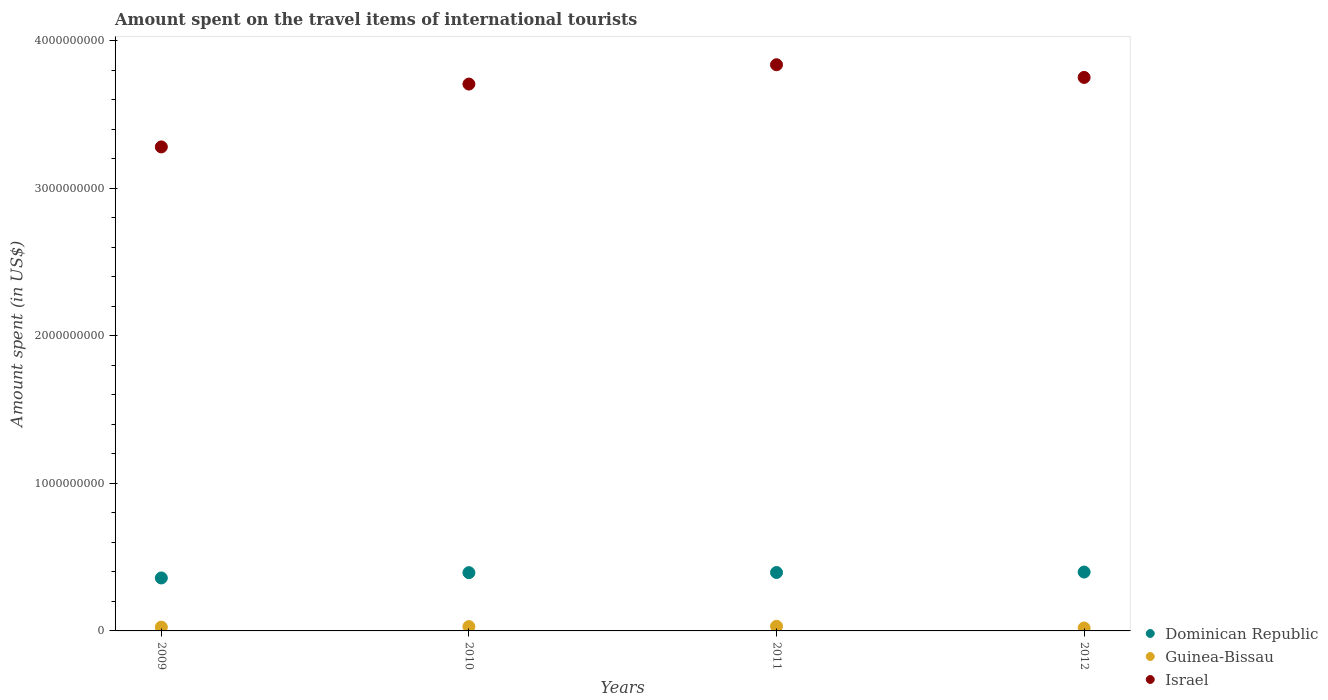What is the amount spent on the travel items of international tourists in Dominican Republic in 2012?
Provide a succinct answer. 3.99e+08. Across all years, what is the maximum amount spent on the travel items of international tourists in Dominican Republic?
Ensure brevity in your answer.  3.99e+08. Across all years, what is the minimum amount spent on the travel items of international tourists in Dominican Republic?
Provide a short and direct response. 3.59e+08. In which year was the amount spent on the travel items of international tourists in Israel maximum?
Your response must be concise. 2011. What is the total amount spent on the travel items of international tourists in Guinea-Bissau in the graph?
Ensure brevity in your answer.  1.06e+08. What is the difference between the amount spent on the travel items of international tourists in Israel in 2011 and that in 2012?
Provide a short and direct response. 8.60e+07. What is the difference between the amount spent on the travel items of international tourists in Dominican Republic in 2011 and the amount spent on the travel items of international tourists in Israel in 2009?
Your response must be concise. -2.88e+09. What is the average amount spent on the travel items of international tourists in Israel per year?
Ensure brevity in your answer.  3.64e+09. In the year 2011, what is the difference between the amount spent on the travel items of international tourists in Israel and amount spent on the travel items of international tourists in Dominican Republic?
Give a very brief answer. 3.44e+09. What is the ratio of the amount spent on the travel items of international tourists in Dominican Republic in 2009 to that in 2010?
Offer a terse response. 0.91. Is the amount spent on the travel items of international tourists in Guinea-Bissau in 2010 less than that in 2012?
Make the answer very short. No. Is the difference between the amount spent on the travel items of international tourists in Israel in 2010 and 2011 greater than the difference between the amount spent on the travel items of international tourists in Dominican Republic in 2010 and 2011?
Your response must be concise. No. What is the difference between the highest and the lowest amount spent on the travel items of international tourists in Dominican Republic?
Keep it short and to the point. 4.00e+07. In how many years, is the amount spent on the travel items of international tourists in Dominican Republic greater than the average amount spent on the travel items of international tourists in Dominican Republic taken over all years?
Provide a short and direct response. 3. Does the amount spent on the travel items of international tourists in Guinea-Bissau monotonically increase over the years?
Your answer should be compact. No. Is the amount spent on the travel items of international tourists in Guinea-Bissau strictly greater than the amount spent on the travel items of international tourists in Israel over the years?
Offer a terse response. No. Is the amount spent on the travel items of international tourists in Israel strictly less than the amount spent on the travel items of international tourists in Guinea-Bissau over the years?
Give a very brief answer. No. How many years are there in the graph?
Your answer should be compact. 4. What is the difference between two consecutive major ticks on the Y-axis?
Your answer should be very brief. 1.00e+09. Are the values on the major ticks of Y-axis written in scientific E-notation?
Provide a short and direct response. No. Does the graph contain any zero values?
Make the answer very short. No. Where does the legend appear in the graph?
Keep it short and to the point. Bottom right. How are the legend labels stacked?
Make the answer very short. Vertical. What is the title of the graph?
Give a very brief answer. Amount spent on the travel items of international tourists. Does "Tanzania" appear as one of the legend labels in the graph?
Your answer should be very brief. No. What is the label or title of the Y-axis?
Offer a very short reply. Amount spent (in US$). What is the Amount spent (in US$) of Dominican Republic in 2009?
Make the answer very short. 3.59e+08. What is the Amount spent (in US$) of Guinea-Bissau in 2009?
Your answer should be compact. 2.57e+07. What is the Amount spent (in US$) of Israel in 2009?
Make the answer very short. 3.28e+09. What is the Amount spent (in US$) of Dominican Republic in 2010?
Your answer should be very brief. 3.95e+08. What is the Amount spent (in US$) of Guinea-Bissau in 2010?
Your answer should be compact. 2.94e+07. What is the Amount spent (in US$) of Israel in 2010?
Provide a short and direct response. 3.71e+09. What is the Amount spent (in US$) of Dominican Republic in 2011?
Your answer should be compact. 3.96e+08. What is the Amount spent (in US$) of Guinea-Bissau in 2011?
Make the answer very short. 3.15e+07. What is the Amount spent (in US$) in Israel in 2011?
Keep it short and to the point. 3.84e+09. What is the Amount spent (in US$) of Dominican Republic in 2012?
Provide a succinct answer. 3.99e+08. What is the Amount spent (in US$) in Guinea-Bissau in 2012?
Your answer should be very brief. 1.98e+07. What is the Amount spent (in US$) of Israel in 2012?
Make the answer very short. 3.75e+09. Across all years, what is the maximum Amount spent (in US$) of Dominican Republic?
Your answer should be very brief. 3.99e+08. Across all years, what is the maximum Amount spent (in US$) in Guinea-Bissau?
Provide a short and direct response. 3.15e+07. Across all years, what is the maximum Amount spent (in US$) in Israel?
Your answer should be compact. 3.84e+09. Across all years, what is the minimum Amount spent (in US$) in Dominican Republic?
Offer a very short reply. 3.59e+08. Across all years, what is the minimum Amount spent (in US$) in Guinea-Bissau?
Give a very brief answer. 1.98e+07. Across all years, what is the minimum Amount spent (in US$) of Israel?
Offer a very short reply. 3.28e+09. What is the total Amount spent (in US$) of Dominican Republic in the graph?
Keep it short and to the point. 1.55e+09. What is the total Amount spent (in US$) of Guinea-Bissau in the graph?
Your answer should be very brief. 1.06e+08. What is the total Amount spent (in US$) of Israel in the graph?
Offer a terse response. 1.46e+1. What is the difference between the Amount spent (in US$) of Dominican Republic in 2009 and that in 2010?
Make the answer very short. -3.60e+07. What is the difference between the Amount spent (in US$) in Guinea-Bissau in 2009 and that in 2010?
Give a very brief answer. -3.70e+06. What is the difference between the Amount spent (in US$) in Israel in 2009 and that in 2010?
Offer a very short reply. -4.26e+08. What is the difference between the Amount spent (in US$) of Dominican Republic in 2009 and that in 2011?
Offer a terse response. -3.70e+07. What is the difference between the Amount spent (in US$) in Guinea-Bissau in 2009 and that in 2011?
Keep it short and to the point. -5.80e+06. What is the difference between the Amount spent (in US$) in Israel in 2009 and that in 2011?
Make the answer very short. -5.57e+08. What is the difference between the Amount spent (in US$) in Dominican Republic in 2009 and that in 2012?
Offer a terse response. -4.00e+07. What is the difference between the Amount spent (in US$) of Guinea-Bissau in 2009 and that in 2012?
Your response must be concise. 5.90e+06. What is the difference between the Amount spent (in US$) in Israel in 2009 and that in 2012?
Offer a terse response. -4.71e+08. What is the difference between the Amount spent (in US$) of Guinea-Bissau in 2010 and that in 2011?
Keep it short and to the point. -2.10e+06. What is the difference between the Amount spent (in US$) of Israel in 2010 and that in 2011?
Your answer should be compact. -1.31e+08. What is the difference between the Amount spent (in US$) in Dominican Republic in 2010 and that in 2012?
Give a very brief answer. -4.00e+06. What is the difference between the Amount spent (in US$) in Guinea-Bissau in 2010 and that in 2012?
Provide a succinct answer. 9.60e+06. What is the difference between the Amount spent (in US$) of Israel in 2010 and that in 2012?
Offer a very short reply. -4.50e+07. What is the difference between the Amount spent (in US$) of Dominican Republic in 2011 and that in 2012?
Give a very brief answer. -3.00e+06. What is the difference between the Amount spent (in US$) in Guinea-Bissau in 2011 and that in 2012?
Provide a succinct answer. 1.17e+07. What is the difference between the Amount spent (in US$) of Israel in 2011 and that in 2012?
Your answer should be compact. 8.60e+07. What is the difference between the Amount spent (in US$) of Dominican Republic in 2009 and the Amount spent (in US$) of Guinea-Bissau in 2010?
Your response must be concise. 3.30e+08. What is the difference between the Amount spent (in US$) of Dominican Republic in 2009 and the Amount spent (in US$) of Israel in 2010?
Your answer should be very brief. -3.35e+09. What is the difference between the Amount spent (in US$) of Guinea-Bissau in 2009 and the Amount spent (in US$) of Israel in 2010?
Keep it short and to the point. -3.68e+09. What is the difference between the Amount spent (in US$) of Dominican Republic in 2009 and the Amount spent (in US$) of Guinea-Bissau in 2011?
Provide a succinct answer. 3.28e+08. What is the difference between the Amount spent (in US$) of Dominican Republic in 2009 and the Amount spent (in US$) of Israel in 2011?
Ensure brevity in your answer.  -3.48e+09. What is the difference between the Amount spent (in US$) in Guinea-Bissau in 2009 and the Amount spent (in US$) in Israel in 2011?
Offer a terse response. -3.81e+09. What is the difference between the Amount spent (in US$) of Dominican Republic in 2009 and the Amount spent (in US$) of Guinea-Bissau in 2012?
Offer a terse response. 3.39e+08. What is the difference between the Amount spent (in US$) of Dominican Republic in 2009 and the Amount spent (in US$) of Israel in 2012?
Your answer should be compact. -3.39e+09. What is the difference between the Amount spent (in US$) in Guinea-Bissau in 2009 and the Amount spent (in US$) in Israel in 2012?
Offer a very short reply. -3.73e+09. What is the difference between the Amount spent (in US$) of Dominican Republic in 2010 and the Amount spent (in US$) of Guinea-Bissau in 2011?
Your response must be concise. 3.64e+08. What is the difference between the Amount spent (in US$) of Dominican Republic in 2010 and the Amount spent (in US$) of Israel in 2011?
Provide a succinct answer. -3.44e+09. What is the difference between the Amount spent (in US$) in Guinea-Bissau in 2010 and the Amount spent (in US$) in Israel in 2011?
Offer a very short reply. -3.81e+09. What is the difference between the Amount spent (in US$) of Dominican Republic in 2010 and the Amount spent (in US$) of Guinea-Bissau in 2012?
Offer a terse response. 3.75e+08. What is the difference between the Amount spent (in US$) in Dominican Republic in 2010 and the Amount spent (in US$) in Israel in 2012?
Your answer should be compact. -3.36e+09. What is the difference between the Amount spent (in US$) of Guinea-Bissau in 2010 and the Amount spent (in US$) of Israel in 2012?
Your response must be concise. -3.72e+09. What is the difference between the Amount spent (in US$) in Dominican Republic in 2011 and the Amount spent (in US$) in Guinea-Bissau in 2012?
Provide a succinct answer. 3.76e+08. What is the difference between the Amount spent (in US$) of Dominican Republic in 2011 and the Amount spent (in US$) of Israel in 2012?
Provide a succinct answer. -3.36e+09. What is the difference between the Amount spent (in US$) of Guinea-Bissau in 2011 and the Amount spent (in US$) of Israel in 2012?
Your answer should be very brief. -3.72e+09. What is the average Amount spent (in US$) in Dominican Republic per year?
Offer a very short reply. 3.87e+08. What is the average Amount spent (in US$) of Guinea-Bissau per year?
Make the answer very short. 2.66e+07. What is the average Amount spent (in US$) in Israel per year?
Provide a short and direct response. 3.64e+09. In the year 2009, what is the difference between the Amount spent (in US$) of Dominican Republic and Amount spent (in US$) of Guinea-Bissau?
Provide a succinct answer. 3.33e+08. In the year 2009, what is the difference between the Amount spent (in US$) of Dominican Republic and Amount spent (in US$) of Israel?
Keep it short and to the point. -2.92e+09. In the year 2009, what is the difference between the Amount spent (in US$) of Guinea-Bissau and Amount spent (in US$) of Israel?
Provide a short and direct response. -3.26e+09. In the year 2010, what is the difference between the Amount spent (in US$) of Dominican Republic and Amount spent (in US$) of Guinea-Bissau?
Your answer should be very brief. 3.66e+08. In the year 2010, what is the difference between the Amount spent (in US$) in Dominican Republic and Amount spent (in US$) in Israel?
Your answer should be very brief. -3.31e+09. In the year 2010, what is the difference between the Amount spent (in US$) in Guinea-Bissau and Amount spent (in US$) in Israel?
Ensure brevity in your answer.  -3.68e+09. In the year 2011, what is the difference between the Amount spent (in US$) in Dominican Republic and Amount spent (in US$) in Guinea-Bissau?
Your answer should be very brief. 3.64e+08. In the year 2011, what is the difference between the Amount spent (in US$) of Dominican Republic and Amount spent (in US$) of Israel?
Your answer should be compact. -3.44e+09. In the year 2011, what is the difference between the Amount spent (in US$) of Guinea-Bissau and Amount spent (in US$) of Israel?
Offer a very short reply. -3.81e+09. In the year 2012, what is the difference between the Amount spent (in US$) of Dominican Republic and Amount spent (in US$) of Guinea-Bissau?
Your answer should be very brief. 3.79e+08. In the year 2012, what is the difference between the Amount spent (in US$) in Dominican Republic and Amount spent (in US$) in Israel?
Give a very brief answer. -3.35e+09. In the year 2012, what is the difference between the Amount spent (in US$) in Guinea-Bissau and Amount spent (in US$) in Israel?
Offer a very short reply. -3.73e+09. What is the ratio of the Amount spent (in US$) of Dominican Republic in 2009 to that in 2010?
Make the answer very short. 0.91. What is the ratio of the Amount spent (in US$) of Guinea-Bissau in 2009 to that in 2010?
Give a very brief answer. 0.87. What is the ratio of the Amount spent (in US$) in Israel in 2009 to that in 2010?
Keep it short and to the point. 0.89. What is the ratio of the Amount spent (in US$) in Dominican Republic in 2009 to that in 2011?
Your answer should be compact. 0.91. What is the ratio of the Amount spent (in US$) in Guinea-Bissau in 2009 to that in 2011?
Ensure brevity in your answer.  0.82. What is the ratio of the Amount spent (in US$) in Israel in 2009 to that in 2011?
Offer a terse response. 0.85. What is the ratio of the Amount spent (in US$) of Dominican Republic in 2009 to that in 2012?
Your response must be concise. 0.9. What is the ratio of the Amount spent (in US$) of Guinea-Bissau in 2009 to that in 2012?
Your answer should be very brief. 1.3. What is the ratio of the Amount spent (in US$) of Israel in 2009 to that in 2012?
Provide a succinct answer. 0.87. What is the ratio of the Amount spent (in US$) of Israel in 2010 to that in 2011?
Provide a short and direct response. 0.97. What is the ratio of the Amount spent (in US$) in Dominican Republic in 2010 to that in 2012?
Offer a terse response. 0.99. What is the ratio of the Amount spent (in US$) in Guinea-Bissau in 2010 to that in 2012?
Make the answer very short. 1.48. What is the ratio of the Amount spent (in US$) of Dominican Republic in 2011 to that in 2012?
Make the answer very short. 0.99. What is the ratio of the Amount spent (in US$) in Guinea-Bissau in 2011 to that in 2012?
Keep it short and to the point. 1.59. What is the ratio of the Amount spent (in US$) of Israel in 2011 to that in 2012?
Your answer should be compact. 1.02. What is the difference between the highest and the second highest Amount spent (in US$) of Dominican Republic?
Keep it short and to the point. 3.00e+06. What is the difference between the highest and the second highest Amount spent (in US$) in Guinea-Bissau?
Provide a succinct answer. 2.10e+06. What is the difference between the highest and the second highest Amount spent (in US$) of Israel?
Give a very brief answer. 8.60e+07. What is the difference between the highest and the lowest Amount spent (in US$) in Dominican Republic?
Offer a very short reply. 4.00e+07. What is the difference between the highest and the lowest Amount spent (in US$) in Guinea-Bissau?
Keep it short and to the point. 1.17e+07. What is the difference between the highest and the lowest Amount spent (in US$) in Israel?
Give a very brief answer. 5.57e+08. 